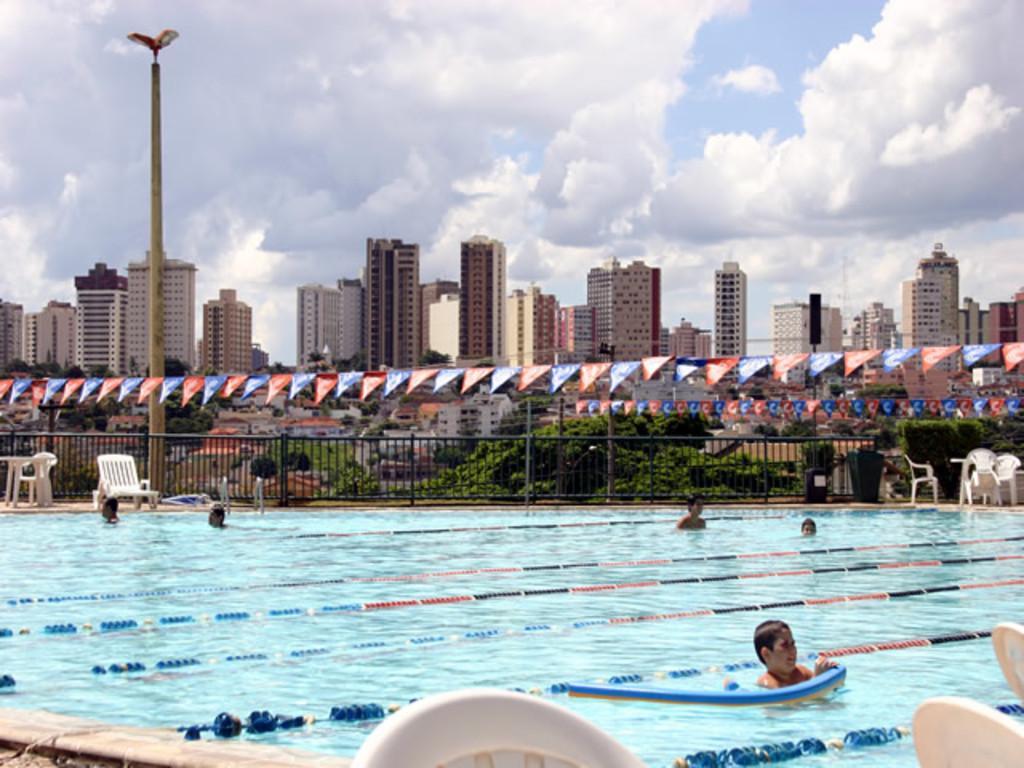Describe this image in one or two sentences. In this picture I can observe a swimming pool. There are some people in the swimming pool. I can observe some chairs on the right side. There is a black color railing. On the left side I can observe a pole. I can observe some buildings and trees in this picture. In the background there is a sky with some clouds. 